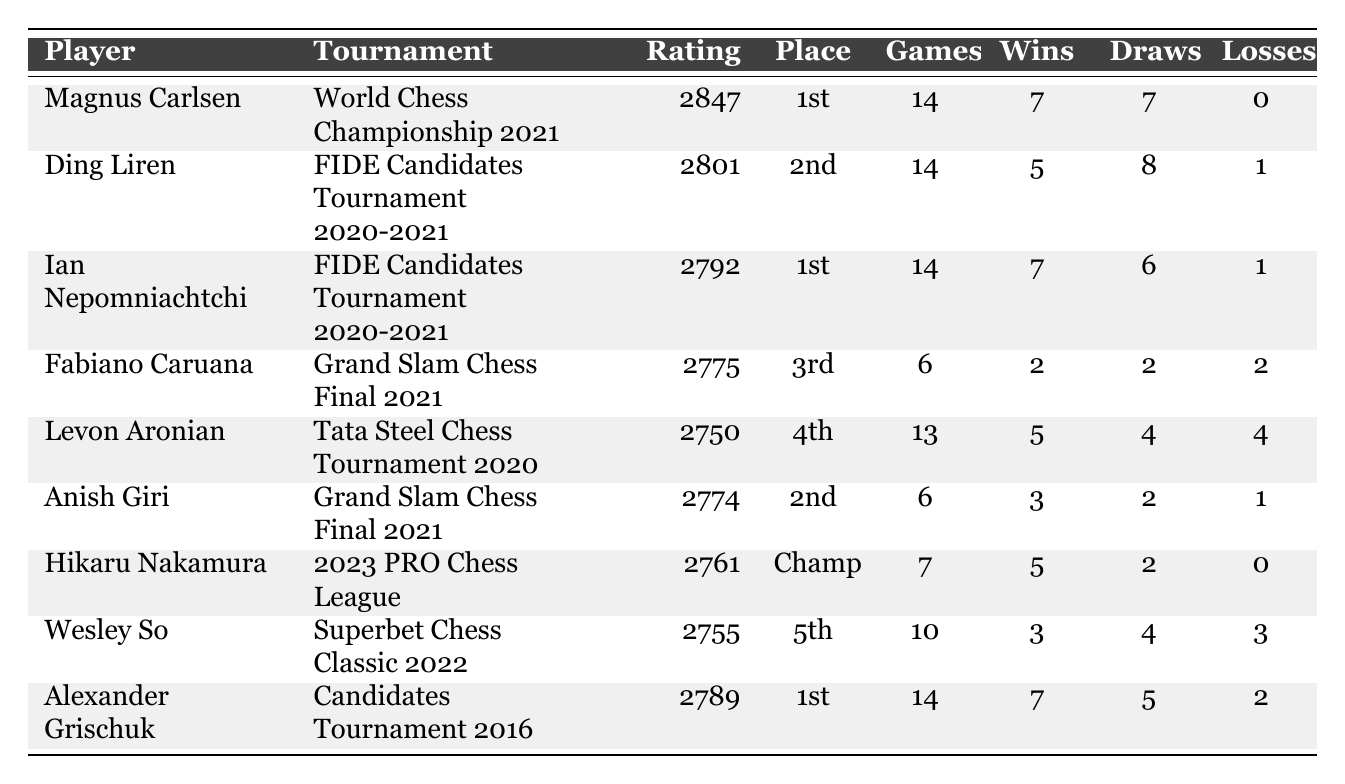What is the performance rating of Magnus Carlsen? The table lists Magnus Carlsen's performance rating as 2847.
Answer: 2847 Who placed 2nd in the FIDE Candidates Tournament 2020-2021? According to the table, Ding Liren placed 2nd in the FIDE Candidates Tournament 2020-2021.
Answer: Ding Liren How many games did Ian Nepomniachtchi play in the FIDE Candidates Tournament 2020-2021? The table shows that Ian Nepomniachtchi played 14 games in the FIDE Candidates Tournament 2020-2021.
Answer: 14 Which player won the 2023 PRO Chess League? The table indicates that Hikaru Nakamura was the Champion of the 2023 PRO Chess League.
Answer: Hikaru Nakamura How many total wins did Magnus Carlsen and Ian Nepomniachtchi have combined? Magnus Carlsen had 7 wins and Ian Nepomniachtchi had 7 wins. Adding them gives 7 + 7 = 14 wins combined.
Answer: 14 What is the average performance rating of all players listed in the table? The performance ratings are 2847, 2801, 2792, 2775, 2750, 2774, 2761, 2755, and 2789. Summing these gives 25069, and dividing by 9 players gives an average rating of 25069 / 9 ≈ 2785.
Answer: Approximately 2785 Did any player finish with zero losses? Magnus Carlsen and Hikaru Nakamura both finished with zero losses according to the table. Therefore, the answer is yes.
Answer: Yes Which tournament had the highest performance rating among the players listed? The highest performance rating listed is 2847 for Magnus Carlsen in the World Chess Championship 2021, making it the tournament with the highest rating.
Answer: World Chess Championship 2021 What is the placement of Fabiano Caruana in the Grand Slam Chess Final 2021? The table shows that Fabiano Caruana placed 3rd in the Grand Slam Chess Final 2021.
Answer: 3rd How many players had more than 5 wins in their tournament? Magnus Carlsen, Ian Nepomniachtchi, and Alexander Grischuk each had more than 5 wins, giving a total of 3 players.
Answer: 3 What is the difference in performance ratings between the 1st and 5th place finishers in the listed tournaments? The 1st place (Magnus Carlsen) had 2847 and the 5th place (Wesley So) had 2755. The difference is 2847 - 2755 = 92.
Answer: 92 